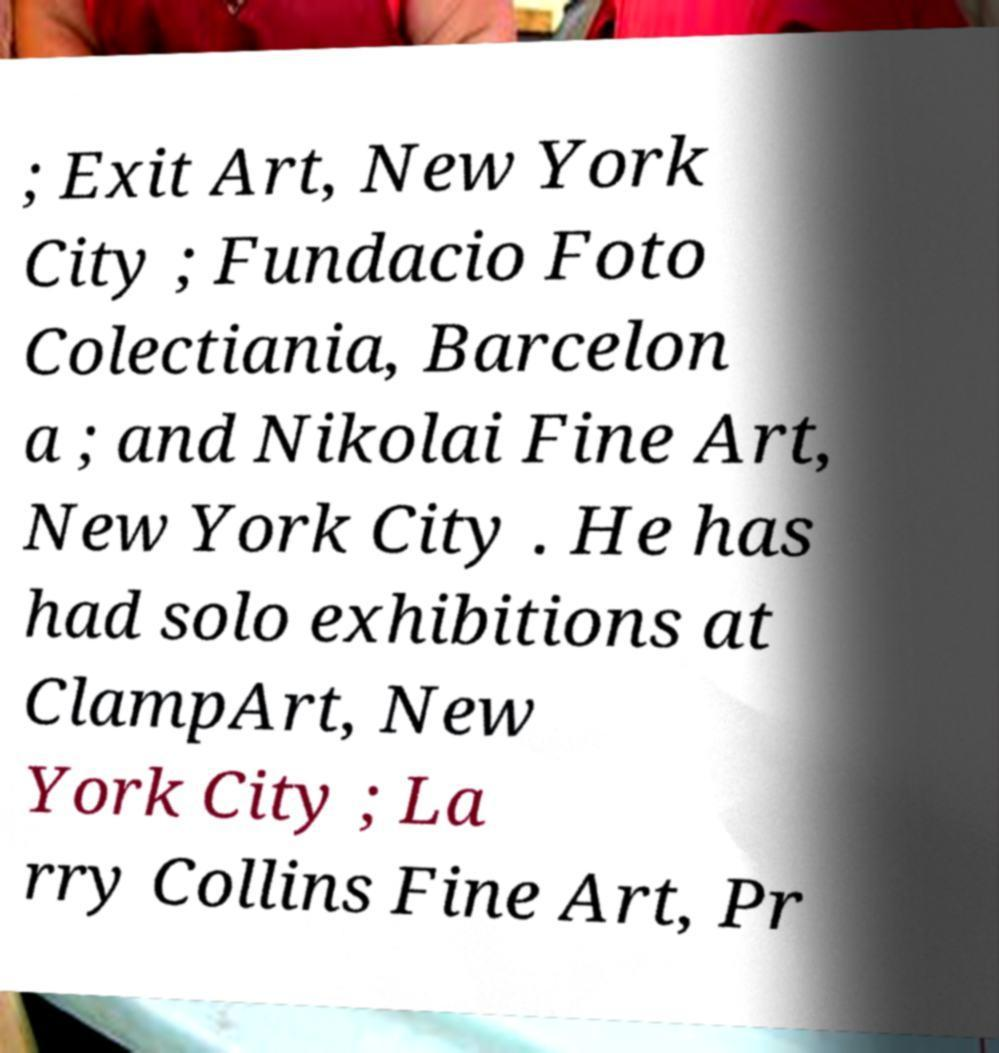Could you extract and type out the text from this image? ; Exit Art, New York City ; Fundacio Foto Colectiania, Barcelon a ; and Nikolai Fine Art, New York City . He has had solo exhibitions at ClampArt, New York City ; La rry Collins Fine Art, Pr 